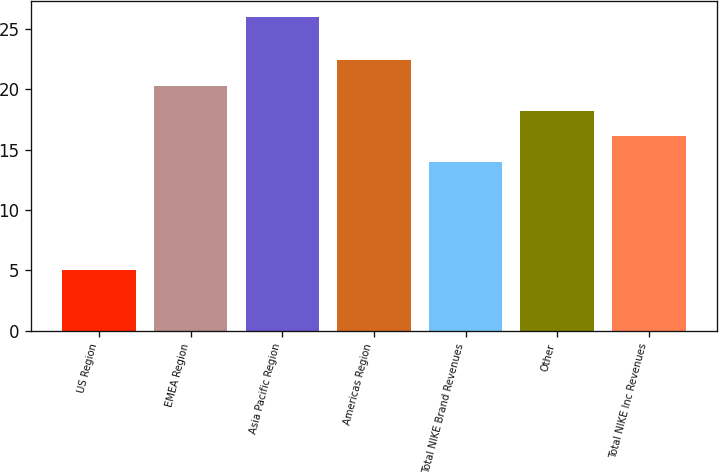Convert chart. <chart><loc_0><loc_0><loc_500><loc_500><bar_chart><fcel>US Region<fcel>EMEA Region<fcel>Asia Pacific Region<fcel>Americas Region<fcel>Total NIKE Brand Revenues<fcel>Other<fcel>Total NIKE Inc Revenues<nl><fcel>5<fcel>20.3<fcel>26<fcel>22.4<fcel>14<fcel>18.2<fcel>16.1<nl></chart> 